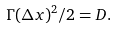<formula> <loc_0><loc_0><loc_500><loc_500>\Gamma ( \Delta x ) ^ { 2 } / 2 = D .</formula> 